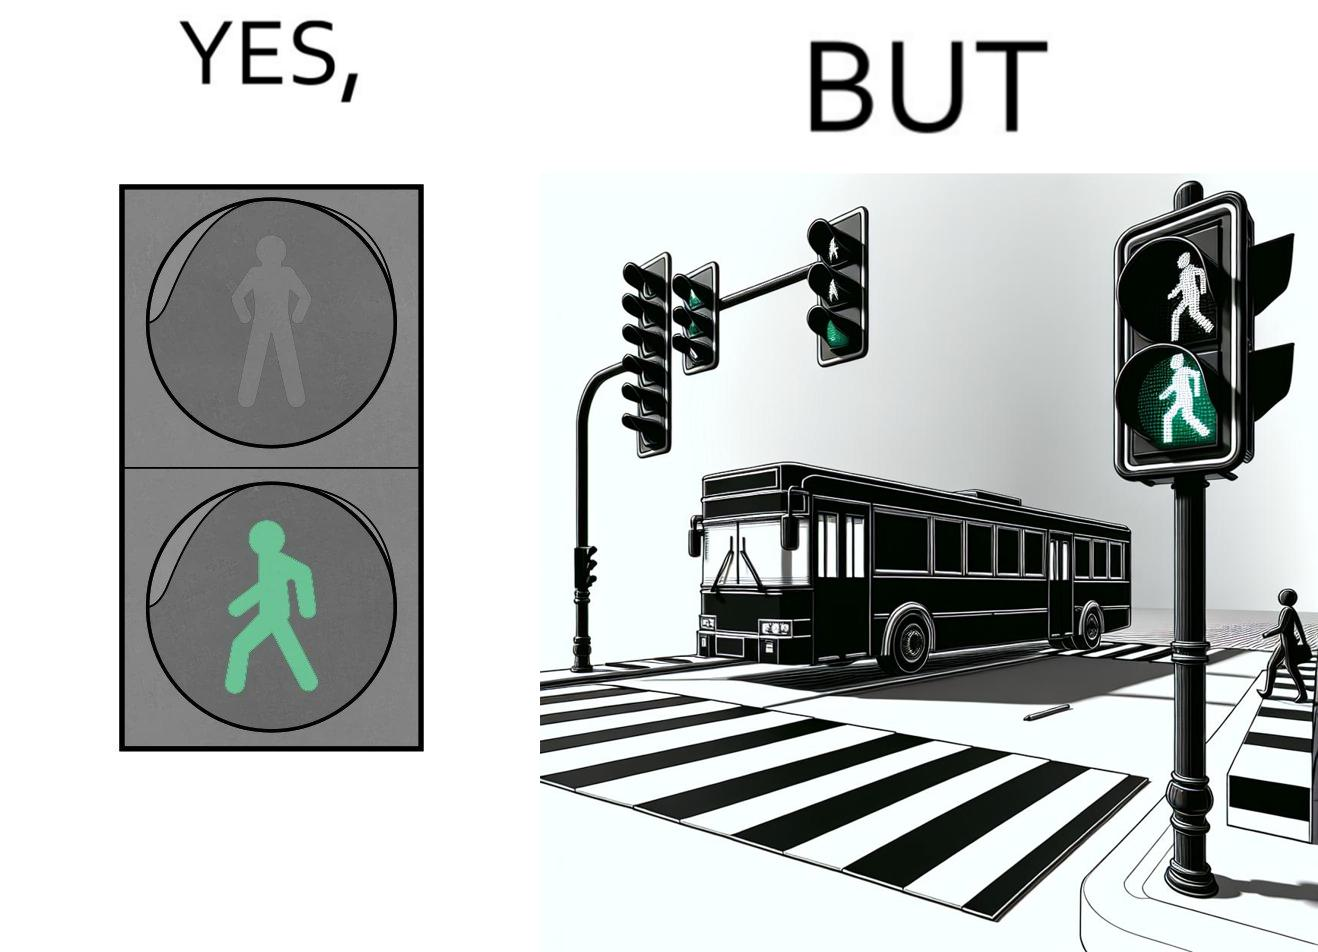Explain the humor or irony in this image. The image is ironic, because even when the signal is green for the pedestrians but they can't cross the road because of the vehicles standing on the zebra crossing 